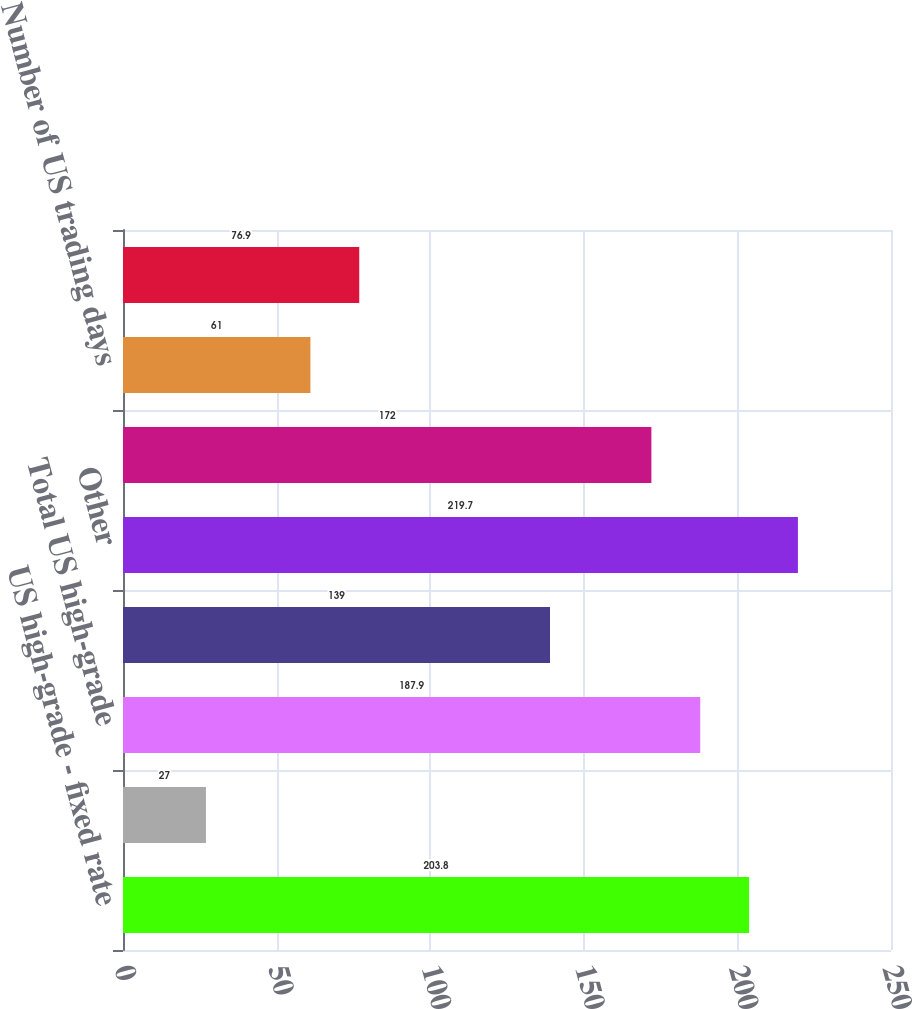<chart> <loc_0><loc_0><loc_500><loc_500><bar_chart><fcel>US high-grade - fixed rate<fcel>US high-grade - floating rate<fcel>Total US high-grade<fcel>Eurobond<fcel>Other<fcel>Total<fcel>Number of US trading days<fcel>Number of UK trading days<nl><fcel>203.8<fcel>27<fcel>187.9<fcel>139<fcel>219.7<fcel>172<fcel>61<fcel>76.9<nl></chart> 